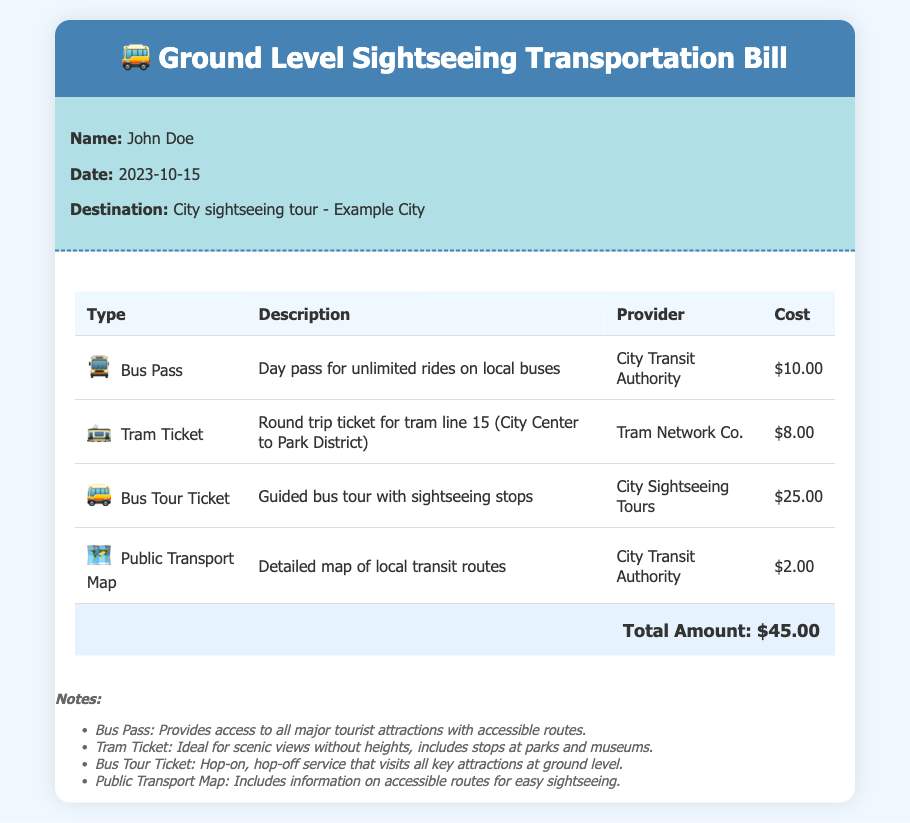What is the total amount? The total amount is listed at the bottom of the expense summary, which sums all the costs provided.
Answer: $45.00 Who is the traveler? The traveler's name is mentioned at the beginning of the document in the traveler details section.
Answer: John Doe What type of transportation is featured in the bill? The bill lists specific types of ground-level transportation suitable for sightseeing.
Answer: Bus and tram What is the cost of the Bus Tour Ticket? The cost of the Bus Tour Ticket is specified in the expense summary table.
Answer: $25.00 What does the Public Transport Map provide? The description of the Public Transport Map indicates its purpose concerning local transit routes for sightseeing.
Answer: Detailed map of local transit routes Which company provides the Bus Pass? The specific provider for the Bus Pass is mentioned next to the item in the expense summary.
Answer: City Transit Authority What type of ticket is described for tram line 15? The description includes details on the kind of ticket purchased for tram line 15.
Answer: Round trip ticket What is highlighted in the notes regarding the Tram Ticket? The notes provide additional insights about the Tram Ticket's suitability for those afraid of heights.
Answer: Ideal for scenic views without heights What does the Bus Pass include? The notes section elaborates on the benefits of the Bus Pass for sightseeing.
Answer: Access to all major tourist attractions with accessible routes 